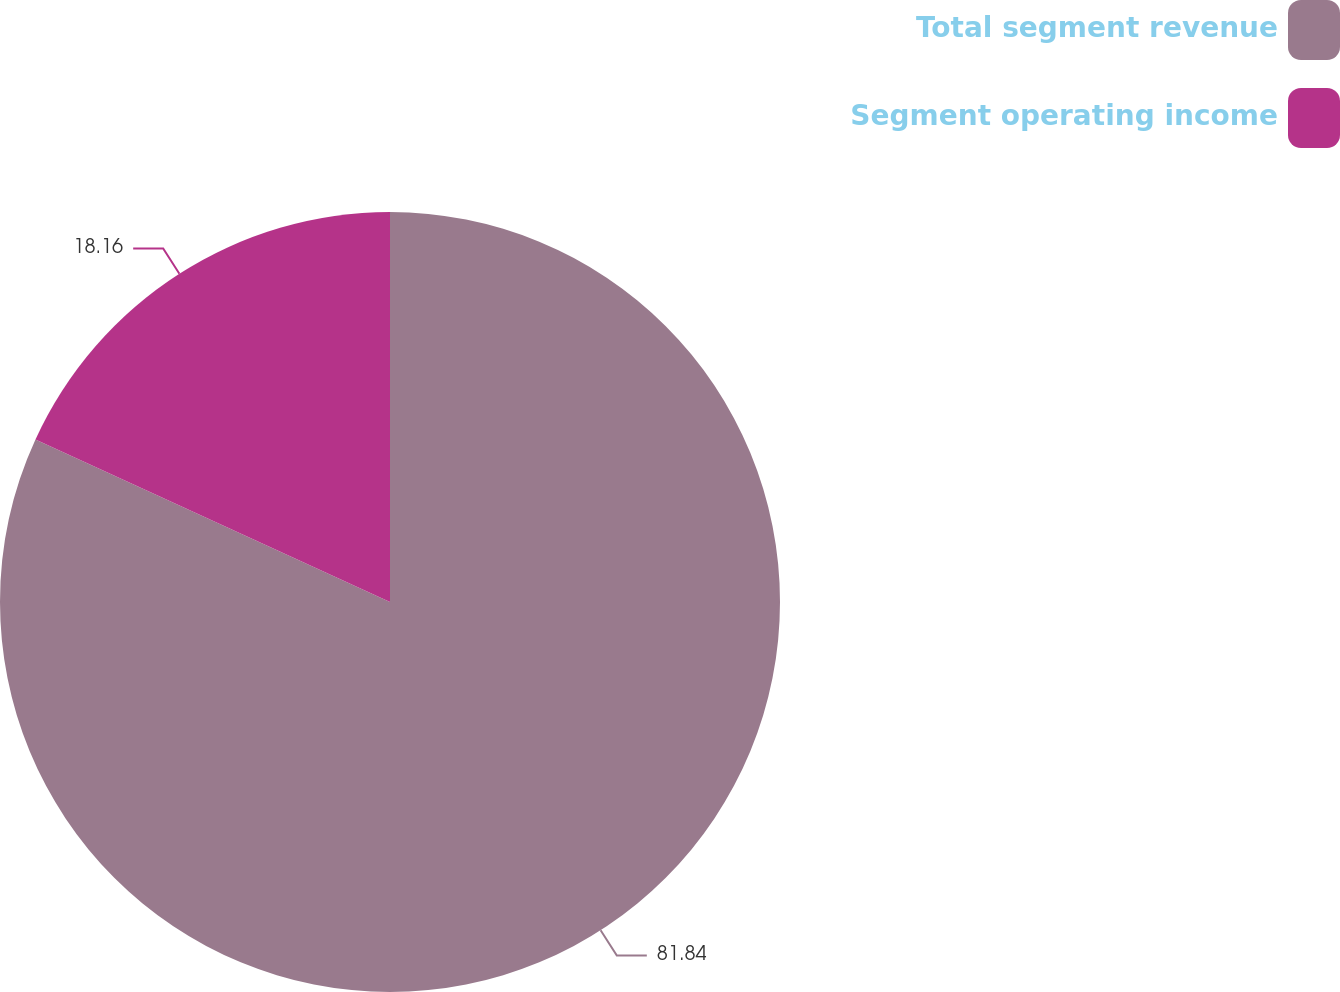Convert chart. <chart><loc_0><loc_0><loc_500><loc_500><pie_chart><fcel>Total segment revenue<fcel>Segment operating income<nl><fcel>81.84%<fcel>18.16%<nl></chart> 